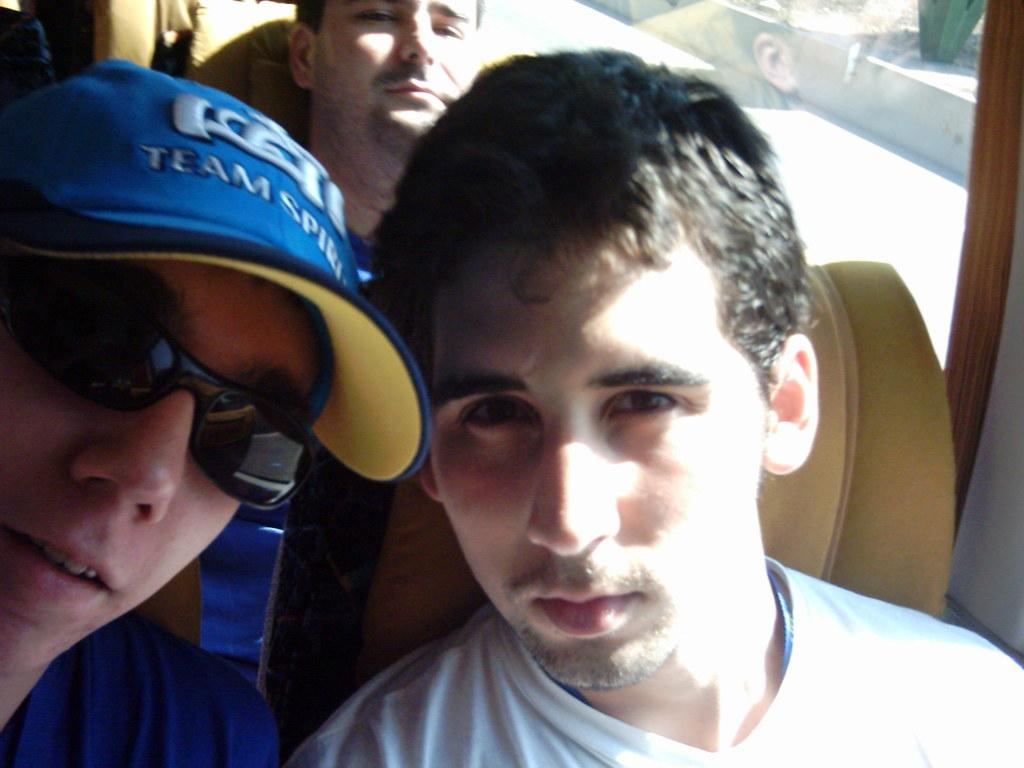How many people are in the vehicle in the image? There are three persons in the vehicle. What are the persons wearing in the image? The persons are wearing goggles. What object can be seen in the vehicle? There is a glass in the vehicle. What is visible through the glass in the image? A road is visible through the glass. How many icicles are hanging from the vehicle in the image? There are no icicles visible in the image. What type of show is being performed by the persons in the vehicle? There is no show being performed by the persons in the vehicle; they are simply wearing goggles and sitting in the vehicle. 